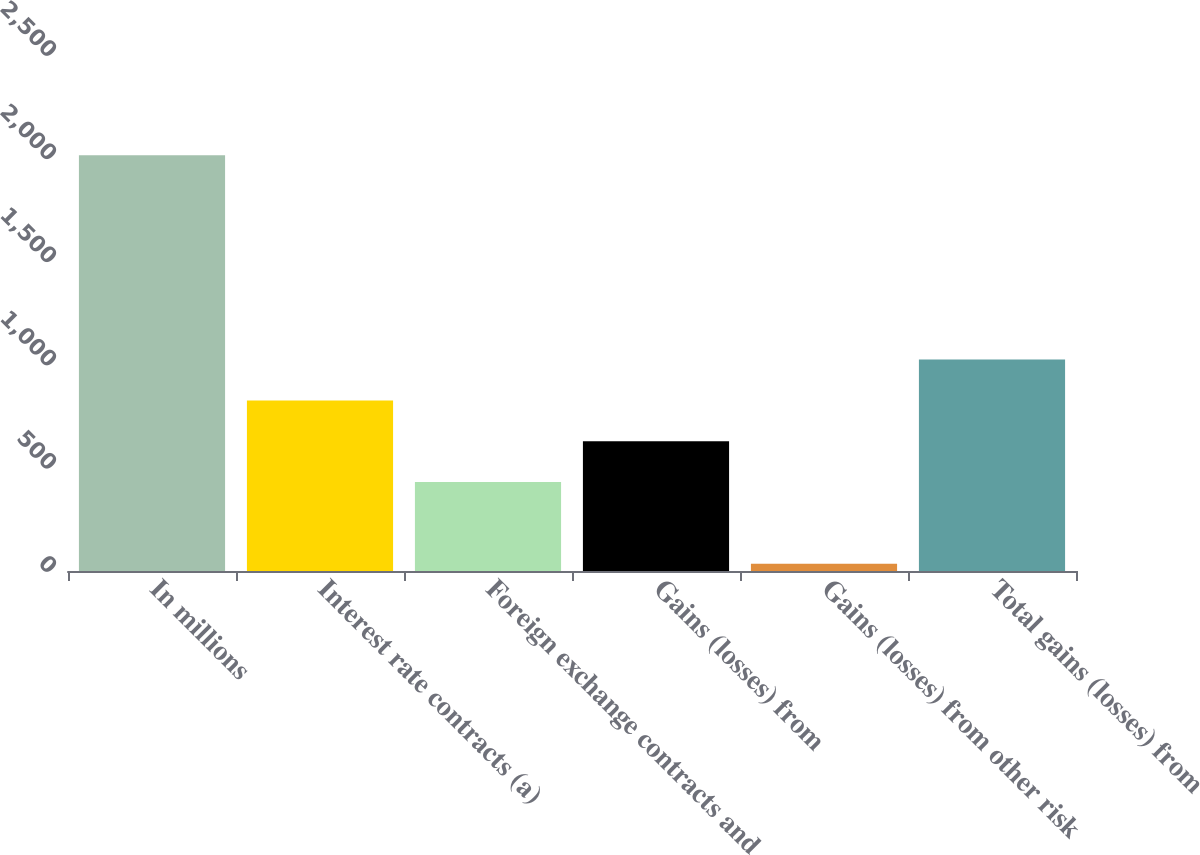Convert chart. <chart><loc_0><loc_0><loc_500><loc_500><bar_chart><fcel>In millions<fcel>Interest rate contracts (a)<fcel>Foreign exchange contracts and<fcel>Gains (losses) from<fcel>Gains (losses) from other risk<fcel>Total gains (losses) from<nl><fcel>2014<fcel>826.6<fcel>430.8<fcel>628.7<fcel>35<fcel>1024.5<nl></chart> 